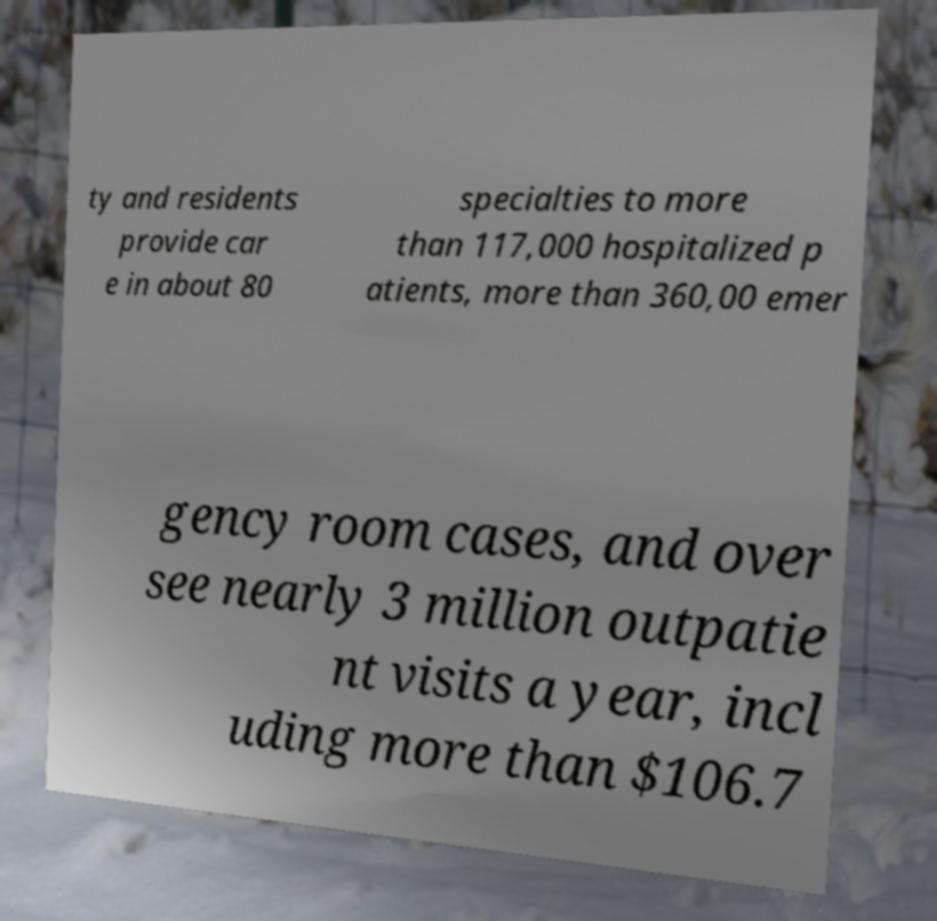Could you assist in decoding the text presented in this image and type it out clearly? ty and residents provide car e in about 80 specialties to more than 117,000 hospitalized p atients, more than 360,00 emer gency room cases, and over see nearly 3 million outpatie nt visits a year, incl uding more than $106.7 